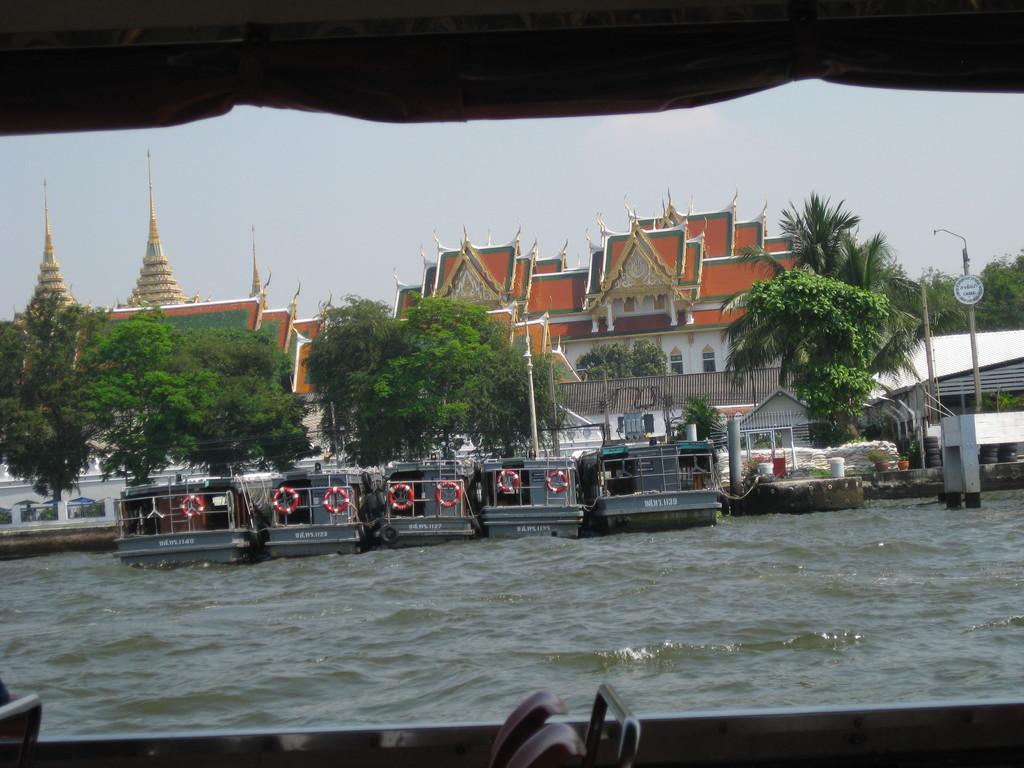Describe this image in one or two sentences. This picture is taken through the boat where we can see a few more boats floating on the water, we can see trees, buildings, poles, and the sky in the background. 